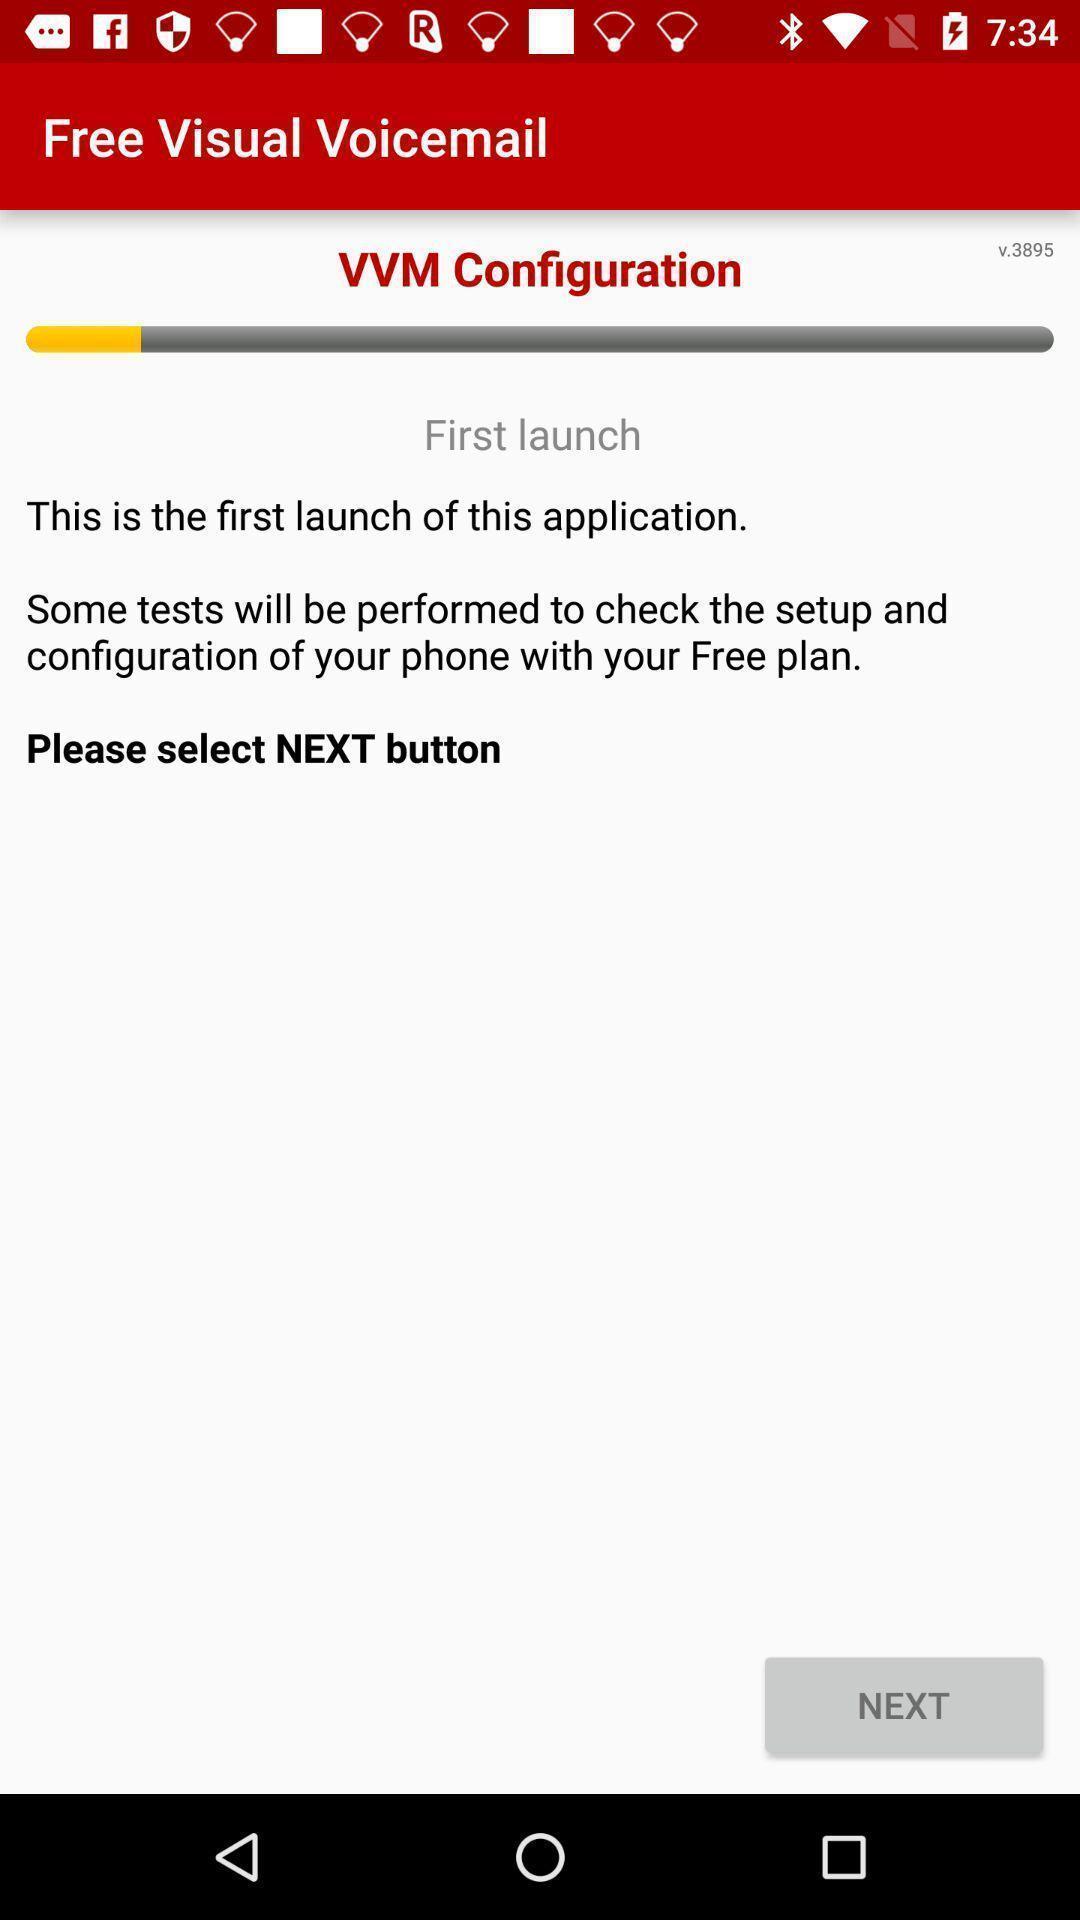Provide a description of this screenshot. Screen displaying configuration page. 